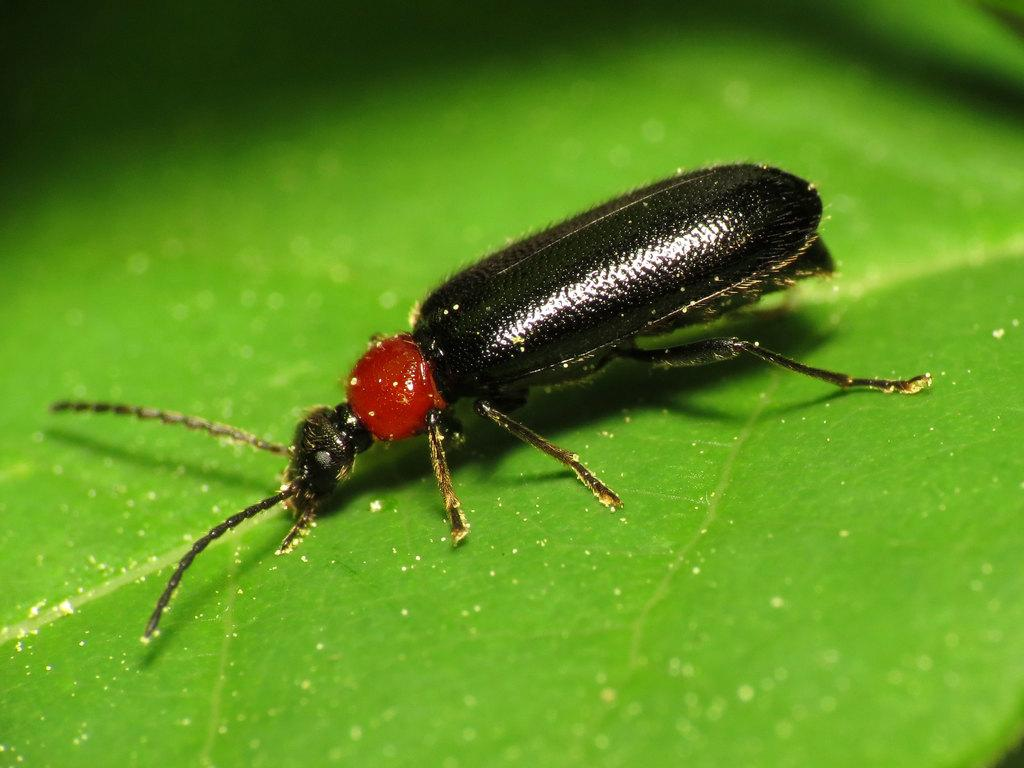What type of creature is in the image? There is an insect in the image. Where is the insect located? The insect is present on a leaf. How many sisters does the insect have in the image? There is no information about the insect's sisters in the image, as it only shows an insect on a leaf. 